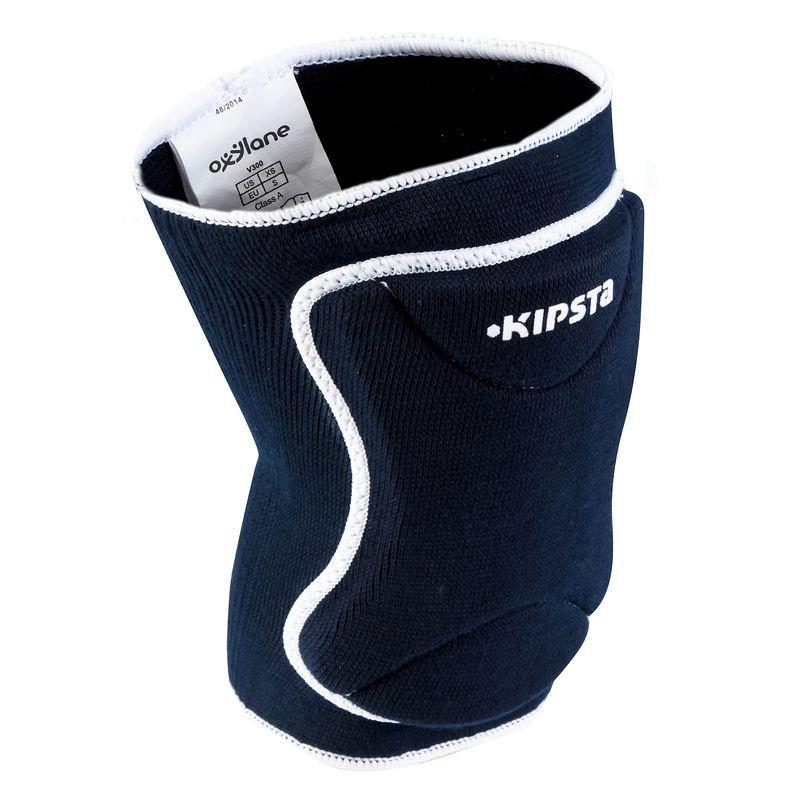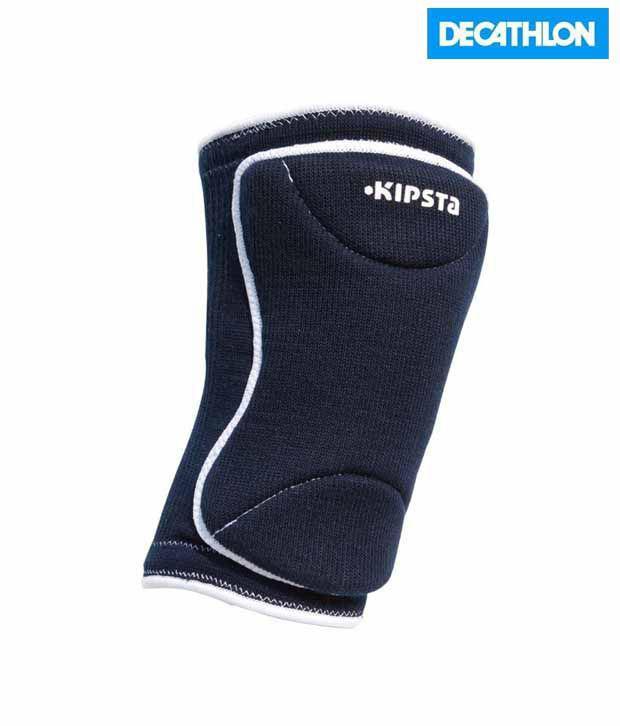The first image is the image on the left, the second image is the image on the right. Given the left and right images, does the statement "One or more of the knee pads has an """"X"""" logo" hold true? Answer yes or no. No. The first image is the image on the left, the second image is the image on the right. Evaluate the accuracy of this statement regarding the images: "At least one padded gear has the letter X on it.". Is it true? Answer yes or no. No. 